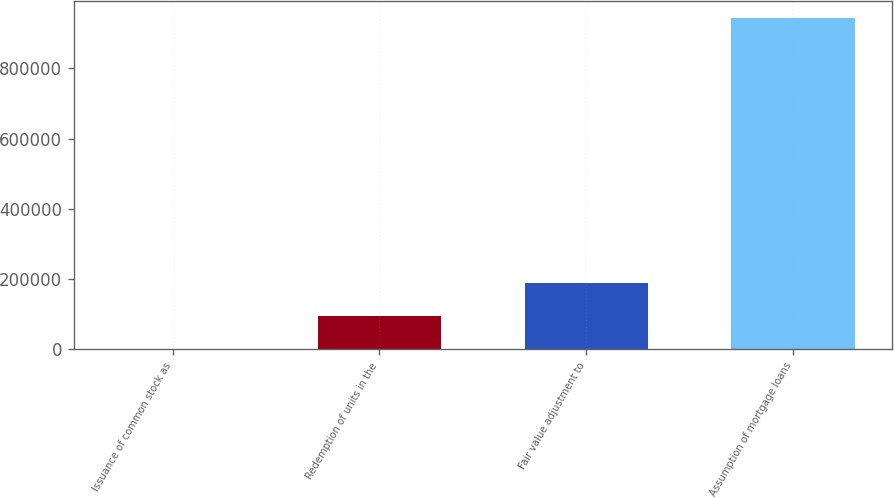<chart> <loc_0><loc_0><loc_500><loc_500><bar_chart><fcel>Issuance of common stock as<fcel>Redemption of units in the<fcel>Fair value adjustment to<fcel>Assumption of mortgage loans<nl><fcel>699<fcel>95005.8<fcel>189313<fcel>943767<nl></chart> 